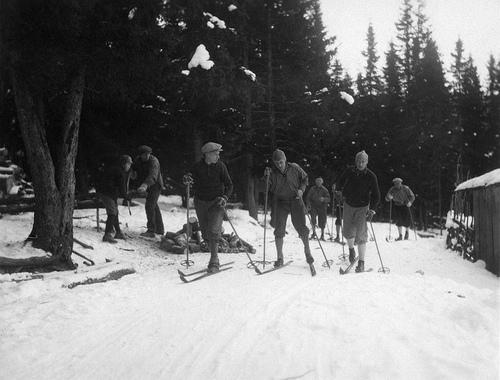Identify the primary activity taking place in the image. People skiing on snow and interacting with each other. Which objects are closest to the skier on the left? A large tree, a pile of logs, and two men sawing wood are closest to the skier on the left. What type of architectural structure can be seen in the image? There is a cabin-like structure on the right side of the scene. Describe the appearance of the trees in the background. The trees in the background are tall, possibly pine trees, and have some snow on them. What is the attire of the man wearing a newsboy hat? The man wearing a newsboy hat has a pole in each hand, is wearing skis, and a dark v-neck sweater over a dark front-button shirt. Give a detailed description of the skier in the middle. The skier in the middle is holding a long ski pole in his right hand, wearing a grey hat, and has curled tips on his skis. Can you count the number of people wearing hats in the image? Yes, all the men, a total of three, are wearing hats in the image. Provide a brief summary of what's happening in this monochrome image. Three men are skiing on snow with tall trees in the background, while two of them interact near a pile of logs and a large tree. Analyze the emotions conveyed by the people and the general atmosphere of the image. The people seem to be enjoying their skiing activity and sharing a friendly atmosphere, with the snowy landscape giving a sense of tranquility and serenity. What is the predominant color of the snow in the scene? The snow is predominantly white in the scene. 